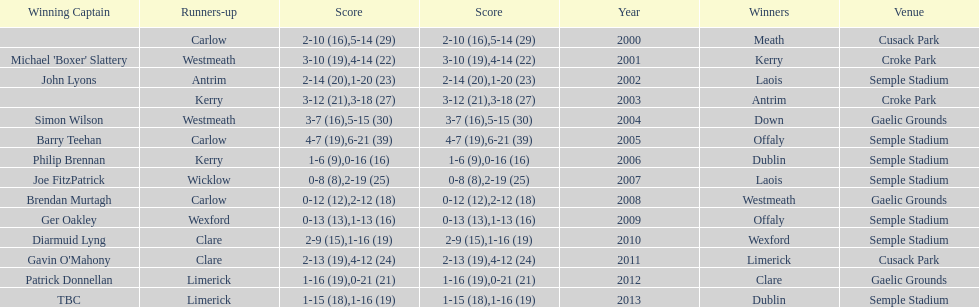Can you parse all the data within this table? {'header': ['Winning Captain', 'Runners-up', 'Score', 'Score', 'Year', 'Winners', 'Venue'], 'rows': [['', 'Carlow', '2-10 (16)', '5-14 (29)', '2000', 'Meath', 'Cusack Park'], ["Michael 'Boxer' Slattery", 'Westmeath', '3-10 (19)', '4-14 (22)', '2001', 'Kerry', 'Croke Park'], ['John Lyons', 'Antrim', '2-14 (20)', '1-20 (23)', '2002', 'Laois', 'Semple Stadium'], ['', 'Kerry', '3-12 (21)', '3-18 (27)', '2003', 'Antrim', 'Croke Park'], ['Simon Wilson', 'Westmeath', '3-7 (16)', '5-15 (30)', '2004', 'Down', 'Gaelic Grounds'], ['Barry Teehan', 'Carlow', '4-7 (19)', '6-21 (39)', '2005', 'Offaly', 'Semple Stadium'], ['Philip Brennan', 'Kerry', '1-6 (9)', '0-16 (16)', '2006', 'Dublin', 'Semple Stadium'], ['Joe FitzPatrick', 'Wicklow', '0-8 (8)', '2-19 (25)', '2007', 'Laois', 'Semple Stadium'], ['Brendan Murtagh', 'Carlow', '0-12 (12)', '2-12 (18)', '2008', 'Westmeath', 'Gaelic Grounds'], ['Ger Oakley', 'Wexford', '0-13 (13)', '1-13 (16)', '2009', 'Offaly', 'Semple Stadium'], ['Diarmuid Lyng', 'Clare', '2-9 (15)', '1-16 (19)', '2010', 'Wexford', 'Semple Stadium'], ["Gavin O'Mahony", 'Clare', '2-13 (19)', '4-12 (24)', '2011', 'Limerick', 'Cusack Park'], ['Patrick Donnellan', 'Limerick', '1-16 (19)', '0-21 (21)', '2012', 'Clare', 'Gaelic Grounds'], ['TBC', 'Limerick', '1-15 (18)', '1-16 (19)', '2013', 'Dublin', 'Semple Stadium']]} Who was the first winner in 2013? Dublin. 